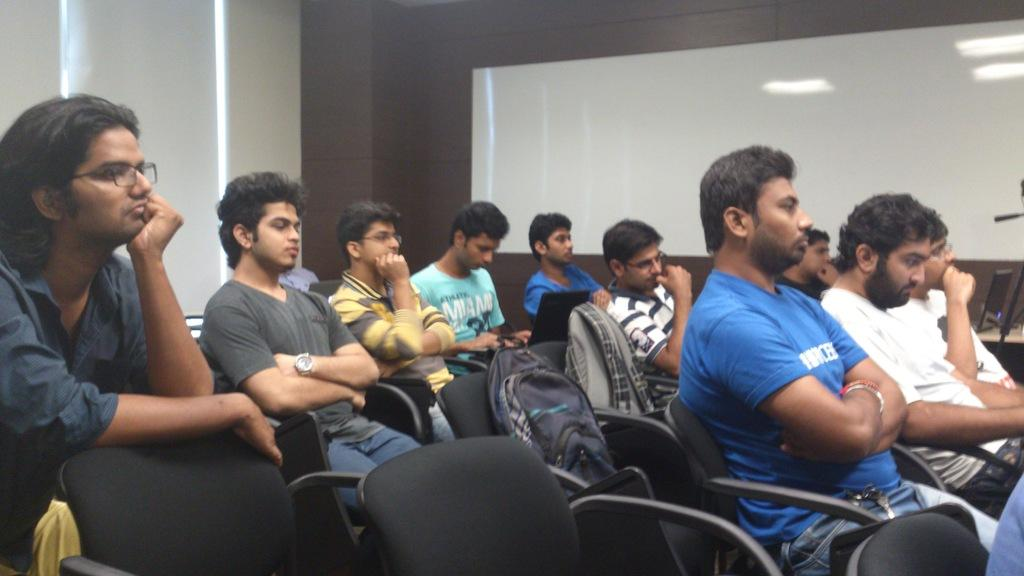What objects are on the black chairs in the foreground of the image? There are bags on the black chairs in the foreground of the image. What are the people in the image doing? People are sitting on the black chairs. What can be seen in the background of the image? There is a board and a wall in the background of the image. What is the taste of the square on the board in the image? There is no square or taste mentioned in the image; it only features bags on black chairs, people sitting, and a board and wall in the background. 